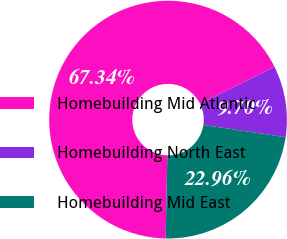<chart> <loc_0><loc_0><loc_500><loc_500><pie_chart><fcel>Homebuilding Mid Atlantic<fcel>Homebuilding North East<fcel>Homebuilding Mid East<nl><fcel>67.34%<fcel>9.7%<fcel>22.96%<nl></chart> 